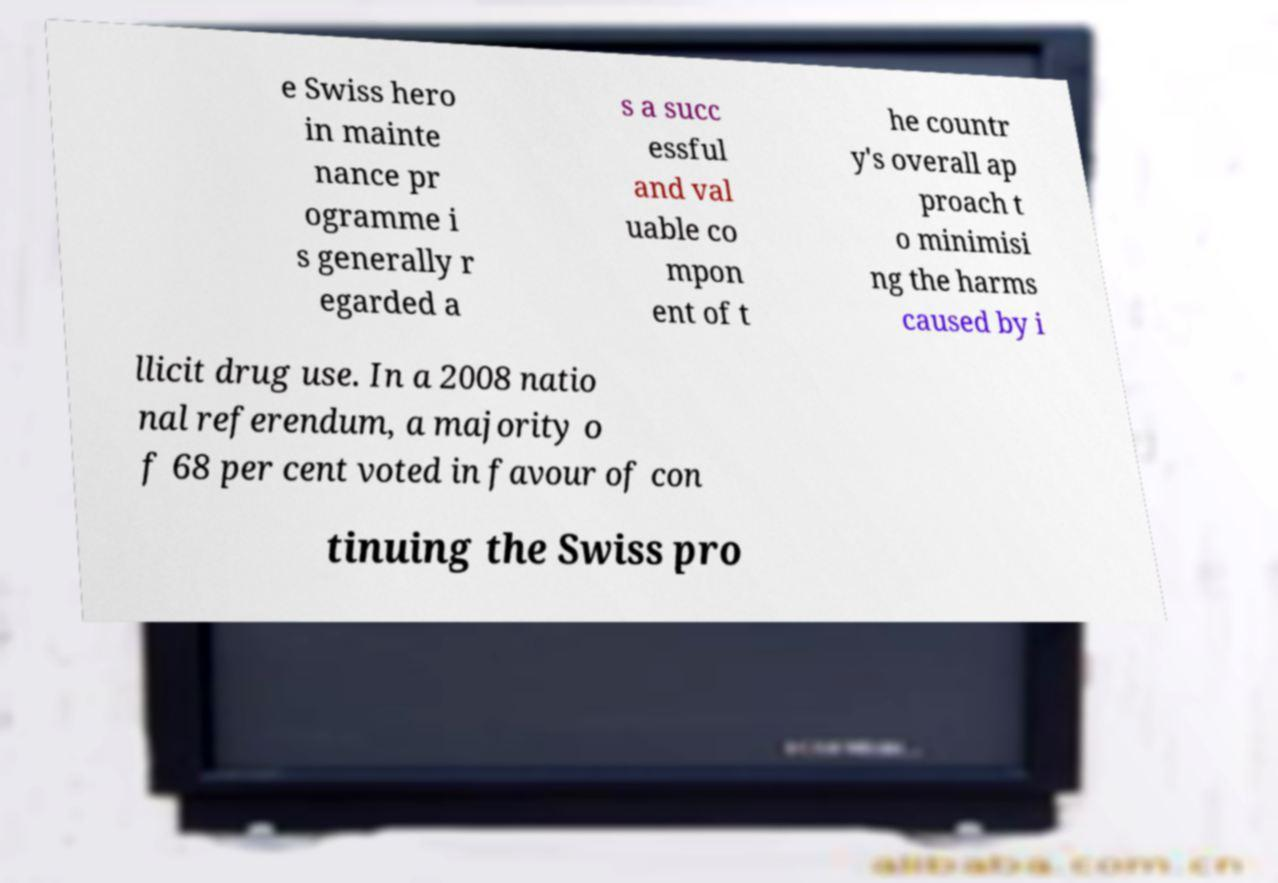For documentation purposes, I need the text within this image transcribed. Could you provide that? e Swiss hero in mainte nance pr ogramme i s generally r egarded a s a succ essful and val uable co mpon ent of t he countr y's overall ap proach t o minimisi ng the harms caused by i llicit drug use. In a 2008 natio nal referendum, a majority o f 68 per cent voted in favour of con tinuing the Swiss pro 